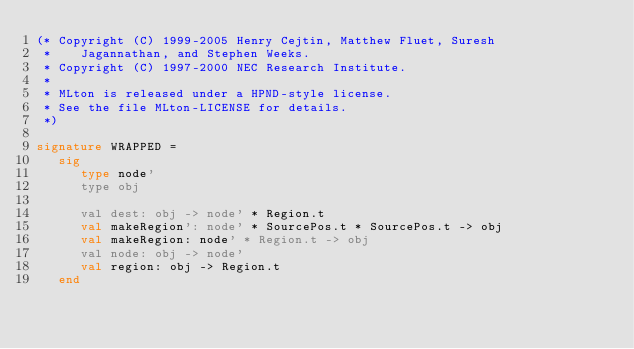Convert code to text. <code><loc_0><loc_0><loc_500><loc_500><_SML_>(* Copyright (C) 1999-2005 Henry Cejtin, Matthew Fluet, Suresh
 *    Jagannathan, and Stephen Weeks.
 * Copyright (C) 1997-2000 NEC Research Institute.
 *
 * MLton is released under a HPND-style license.
 * See the file MLton-LICENSE for details.
 *)

signature WRAPPED =
   sig
      type node'
      type obj

      val dest: obj -> node' * Region.t
      val makeRegion': node' * SourcePos.t * SourcePos.t -> obj
      val makeRegion: node' * Region.t -> obj
      val node: obj -> node'
      val region: obj -> Region.t
   end
</code> 